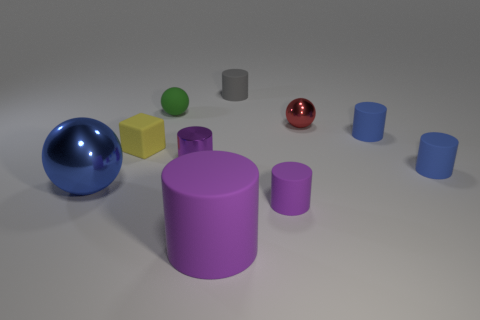How many objects are things in front of the green ball or cylinders that are in front of the red ball?
Ensure brevity in your answer.  8. Are the small gray cylinder and the blue thing left of the red metal object made of the same material?
Provide a short and direct response. No. How many other objects are there of the same shape as the yellow matte thing?
Provide a short and direct response. 0. What material is the cylinder in front of the tiny purple thing that is on the right side of the big object that is in front of the big blue metal thing?
Keep it short and to the point. Rubber. Is the number of small green rubber spheres in front of the purple shiny thing the same as the number of gray rubber cylinders?
Offer a terse response. No. Does the tiny object that is in front of the large blue metallic ball have the same material as the sphere that is in front of the purple metallic cylinder?
Ensure brevity in your answer.  No. Are there any other things that are made of the same material as the big purple object?
Give a very brief answer. Yes. There is a blue thing left of the yellow rubber thing; does it have the same shape as the tiny metal thing that is left of the gray cylinder?
Provide a short and direct response. No. Is the number of tiny red things that are behind the green sphere less than the number of tiny blue matte objects?
Ensure brevity in your answer.  Yes. How many small matte cylinders are the same color as the big rubber cylinder?
Ensure brevity in your answer.  1. 